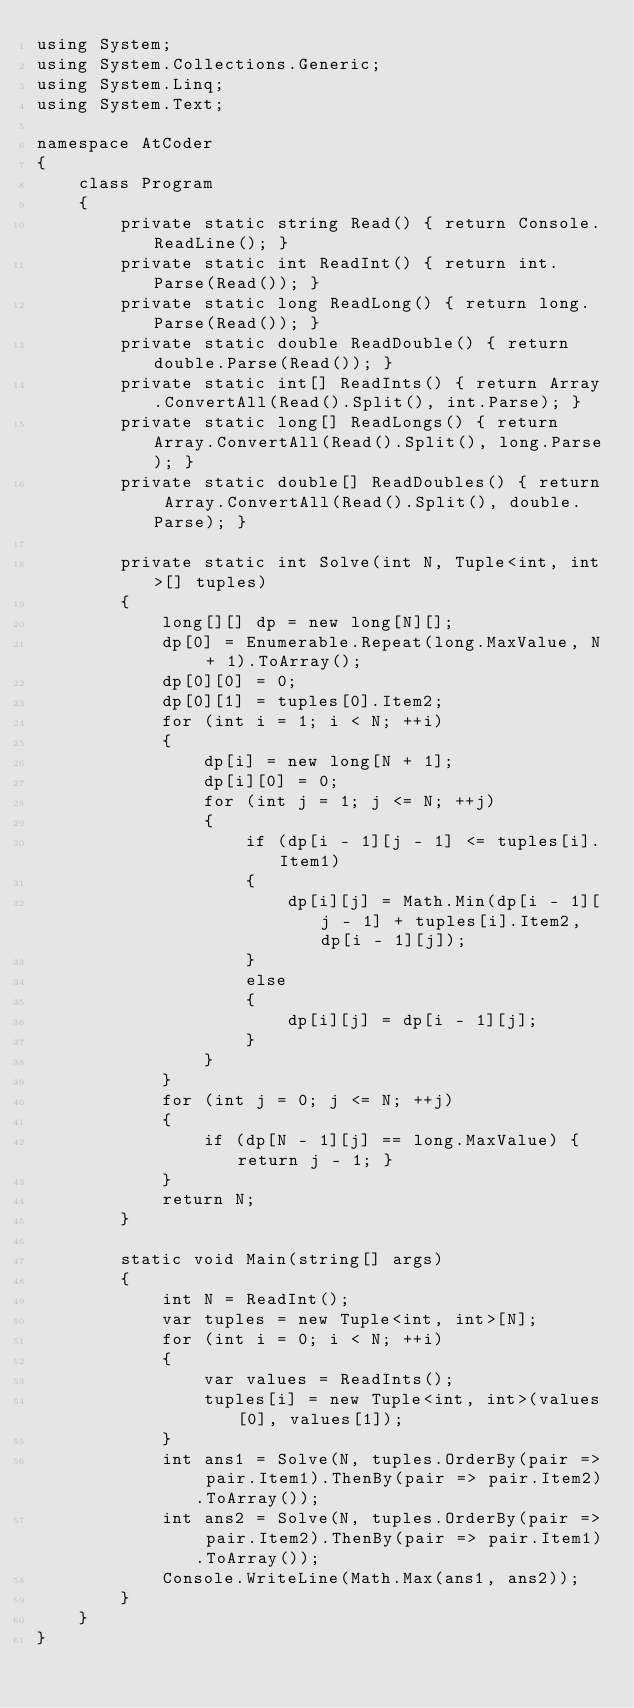Convert code to text. <code><loc_0><loc_0><loc_500><loc_500><_C#_>using System;
using System.Collections.Generic;
using System.Linq;
using System.Text;

namespace AtCoder
{
    class Program
    {
        private static string Read() { return Console.ReadLine(); }
        private static int ReadInt() { return int.Parse(Read()); }
        private static long ReadLong() { return long.Parse(Read()); }
        private static double ReadDouble() { return double.Parse(Read()); }
        private static int[] ReadInts() { return Array.ConvertAll(Read().Split(), int.Parse); }
        private static long[] ReadLongs() { return Array.ConvertAll(Read().Split(), long.Parse); }
        private static double[] ReadDoubles() { return Array.ConvertAll(Read().Split(), double.Parse); }

        private static int Solve(int N, Tuple<int, int>[] tuples)
        {
            long[][] dp = new long[N][];
            dp[0] = Enumerable.Repeat(long.MaxValue, N + 1).ToArray();
            dp[0][0] = 0;
            dp[0][1] = tuples[0].Item2;
            for (int i = 1; i < N; ++i)
            {
                dp[i] = new long[N + 1];
                dp[i][0] = 0;
                for (int j = 1; j <= N; ++j)
                {
                    if (dp[i - 1][j - 1] <= tuples[i].Item1)
                    {
                        dp[i][j] = Math.Min(dp[i - 1][j - 1] + tuples[i].Item2, dp[i - 1][j]);
                    }
                    else
                    {
                        dp[i][j] = dp[i - 1][j];
                    }
                }
            }
            for (int j = 0; j <= N; ++j)
            {
                if (dp[N - 1][j] == long.MaxValue) { return j - 1; }
            }
            return N;
        }

        static void Main(string[] args)
        {
            int N = ReadInt();
            var tuples = new Tuple<int, int>[N];
            for (int i = 0; i < N; ++i)
            {
                var values = ReadInts();
                tuples[i] = new Tuple<int, int>(values[0], values[1]);
            }
            int ans1 = Solve(N, tuples.OrderBy(pair => pair.Item1).ThenBy(pair => pair.Item2).ToArray());
            int ans2 = Solve(N, tuples.OrderBy(pair => pair.Item2).ThenBy(pair => pair.Item1).ToArray());
            Console.WriteLine(Math.Max(ans1, ans2));
        }
    }
}
</code> 